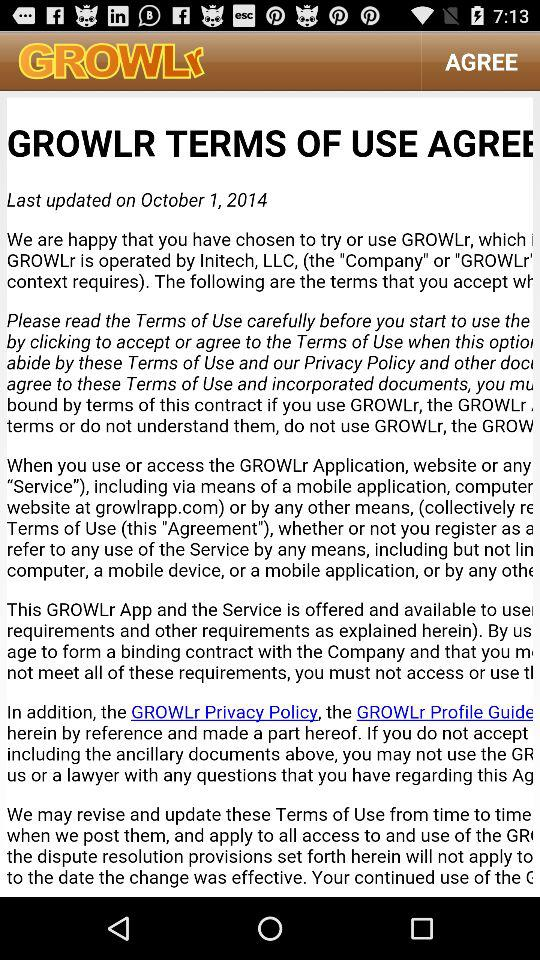When was the agreement updated? The agreement was updated on October 1, 2014. 